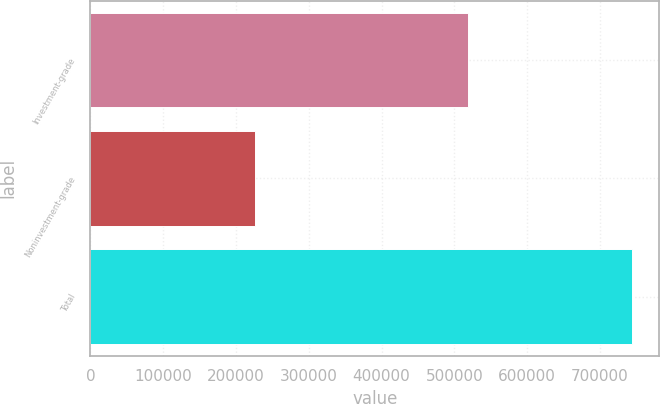Convert chart to OTSL. <chart><loc_0><loc_0><loc_500><loc_500><bar_chart><fcel>Investment-grade<fcel>Noninvestment-grade<fcel>Total<nl><fcel>518441<fcel>225958<fcel>744399<nl></chart> 